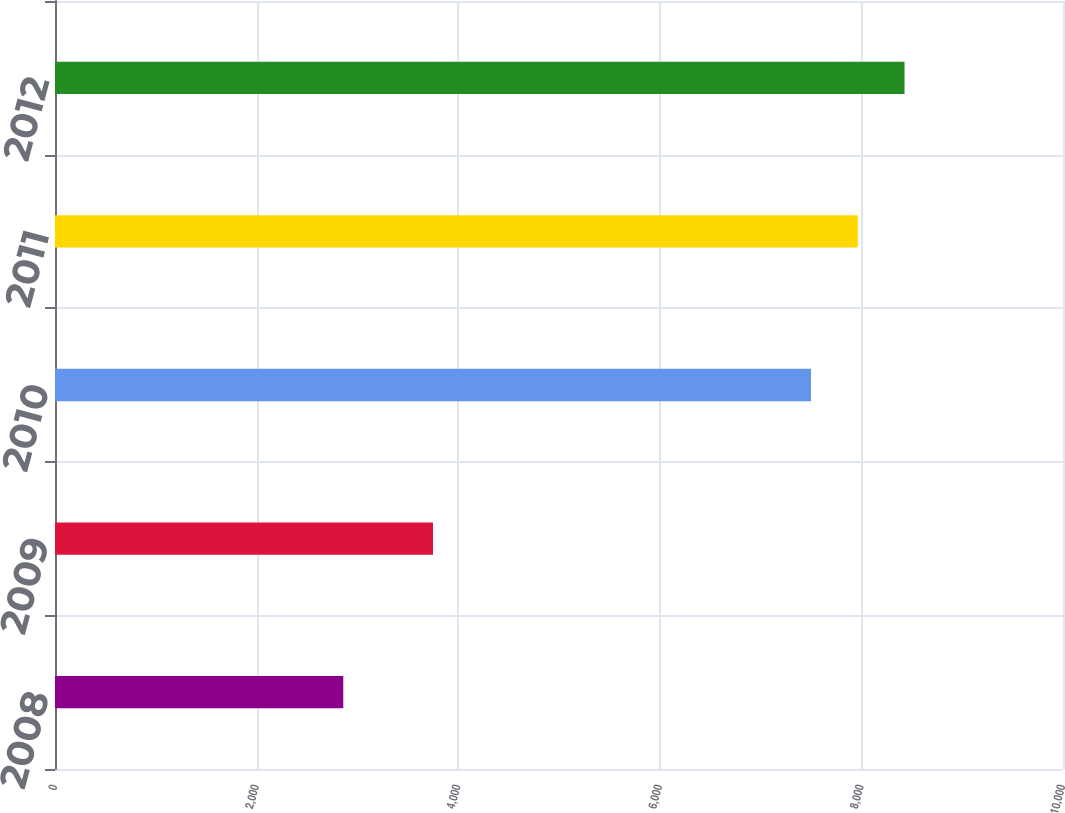Convert chart to OTSL. <chart><loc_0><loc_0><loc_500><loc_500><bar_chart><fcel>2008<fcel>2009<fcel>2010<fcel>2011<fcel>2012<nl><fcel>2860<fcel>3750<fcel>7500<fcel>7964<fcel>8428<nl></chart> 